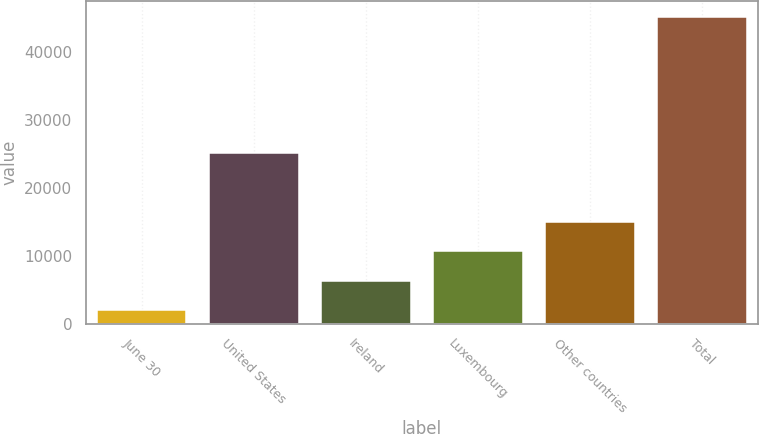<chart> <loc_0><loc_0><loc_500><loc_500><bar_chart><fcel>June 30<fcel>United States<fcel>Ireland<fcel>Luxembourg<fcel>Other countries<fcel>Total<nl><fcel>2016<fcel>25145<fcel>6330.3<fcel>10644.6<fcel>14958.9<fcel>45159<nl></chart> 